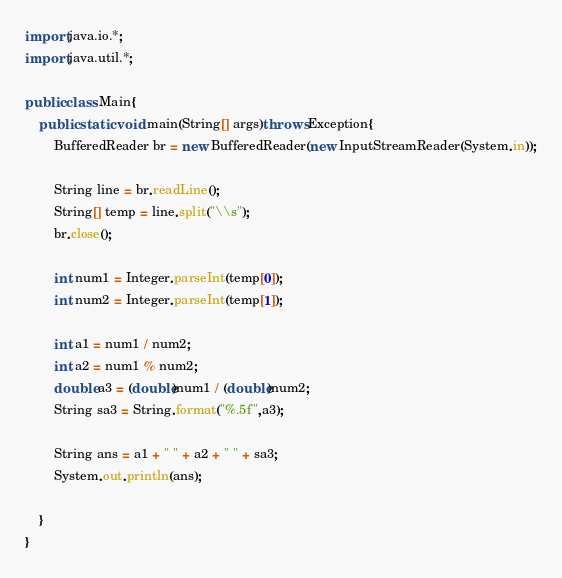<code> <loc_0><loc_0><loc_500><loc_500><_Java_>import java.io.*;
import java.util.*;

public class Main{
    public static void main(String[] args)throws Exception{
        BufferedReader br = new BufferedReader(new InputStreamReader(System.in));
        
        String line = br.readLine();
        String[] temp = line.split("\\s");
        br.close();

        int num1 = Integer.parseInt(temp[0]);
        int num2 = Integer.parseInt(temp[1]);
        
        int a1 = num1 / num2;
        int a2 = num1 % num2;
        double a3 = (double)num1 / (double)num2;
        String sa3 = String.format("%.5f",a3);

        String ans = a1 + " " + a2 + " " + sa3;
        System.out.println(ans);

    }
}</code> 